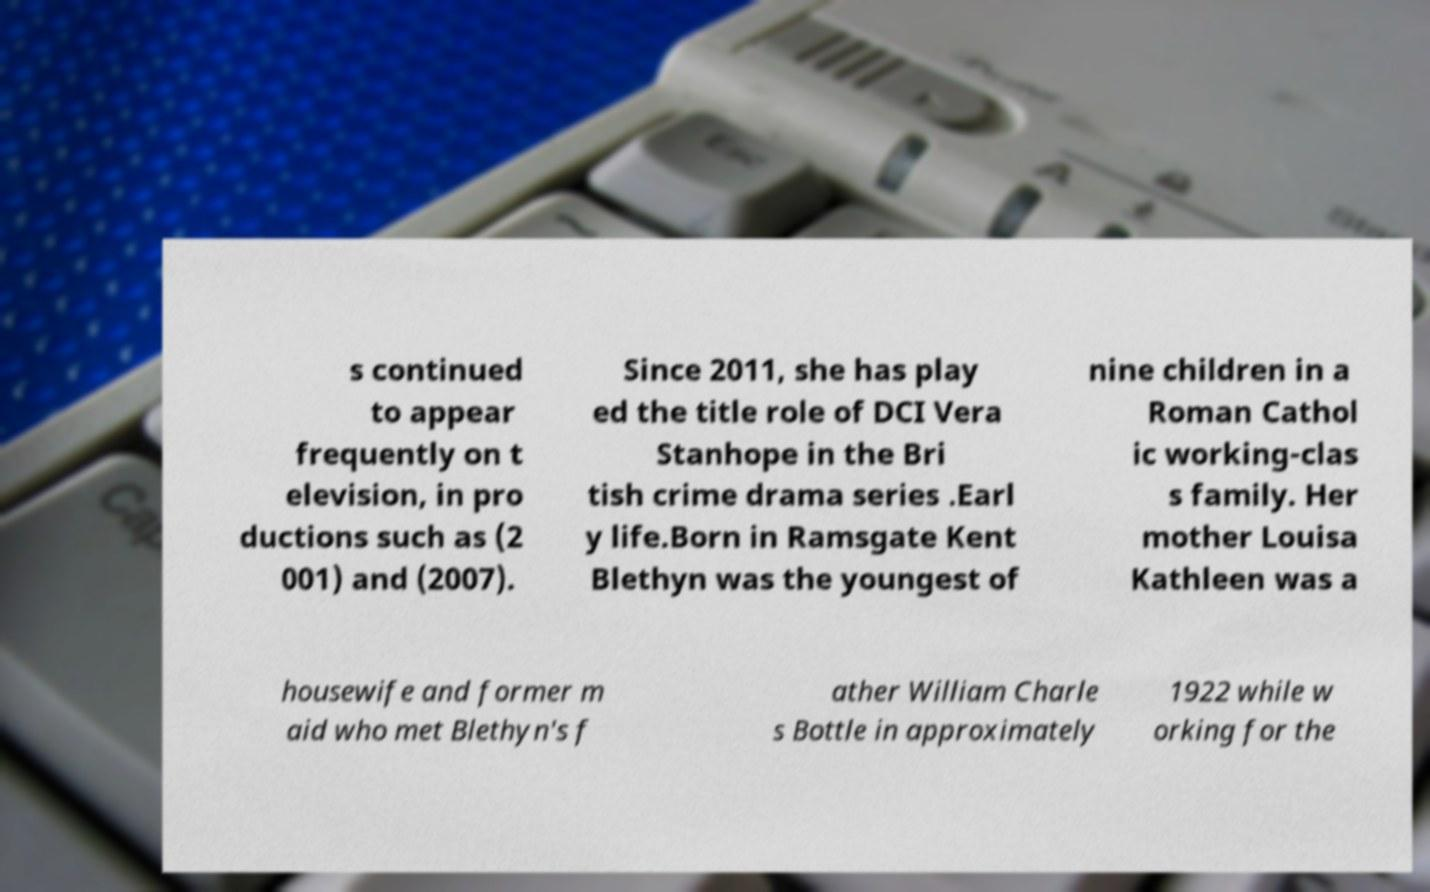Please read and relay the text visible in this image. What does it say? s continued to appear frequently on t elevision, in pro ductions such as (2 001) and (2007). Since 2011, she has play ed the title role of DCI Vera Stanhope in the Bri tish crime drama series .Earl y life.Born in Ramsgate Kent Blethyn was the youngest of nine children in a Roman Cathol ic working-clas s family. Her mother Louisa Kathleen was a housewife and former m aid who met Blethyn's f ather William Charle s Bottle in approximately 1922 while w orking for the 